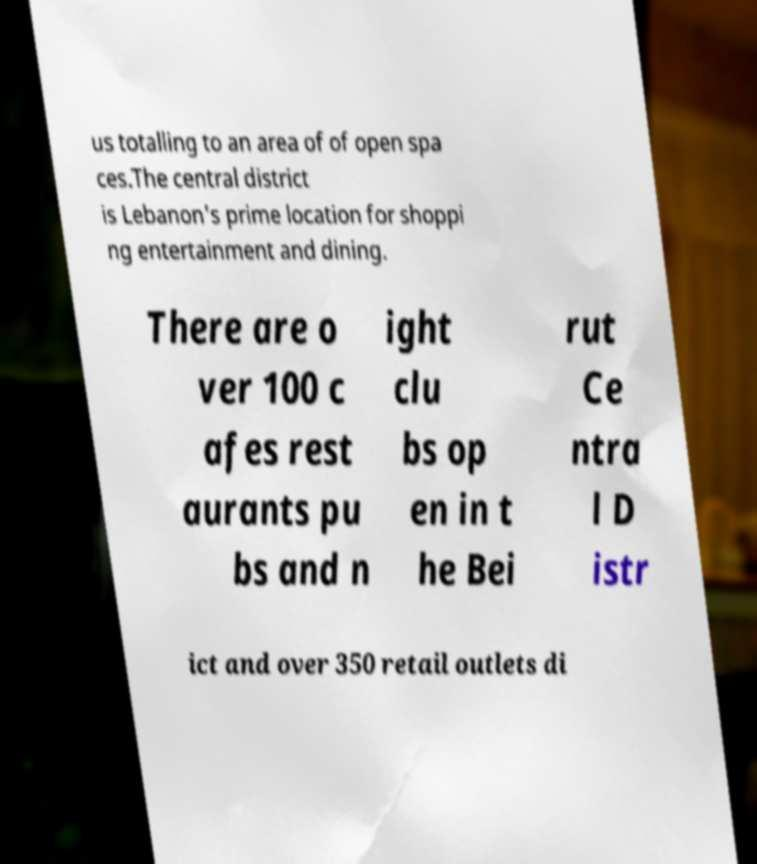Can you read and provide the text displayed in the image?This photo seems to have some interesting text. Can you extract and type it out for me? us totalling to an area of of open spa ces.The central district is Lebanon's prime location for shoppi ng entertainment and dining. There are o ver 100 c afes rest aurants pu bs and n ight clu bs op en in t he Bei rut Ce ntra l D istr ict and over 350 retail outlets di 